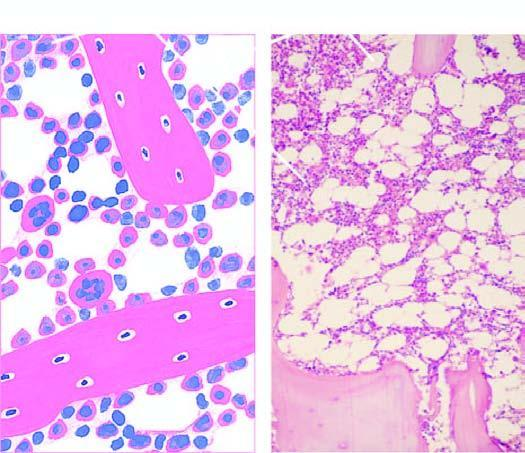s left side seen in a section after trephine biopsy?
Answer the question using a single word or phrase. No 